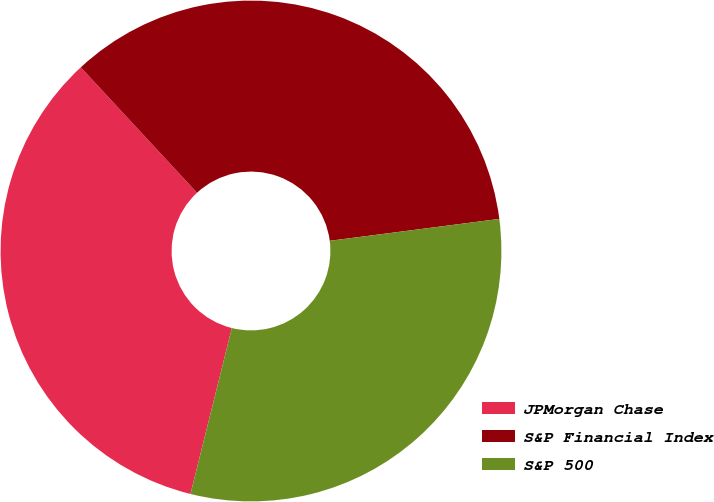<chart> <loc_0><loc_0><loc_500><loc_500><pie_chart><fcel>JPMorgan Chase<fcel>S&P Financial Index<fcel>S&P 500<nl><fcel>34.22%<fcel>34.85%<fcel>30.93%<nl></chart> 